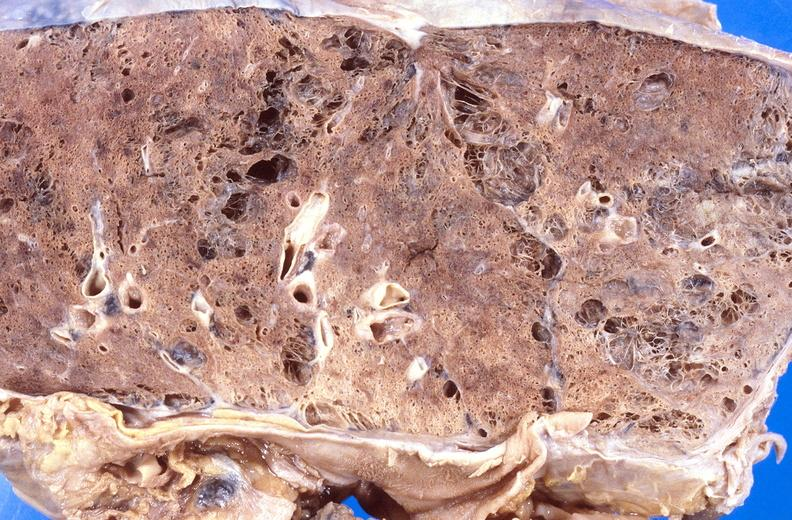does this image show cryptococcal pneumonia?
Answer the question using a single word or phrase. Yes 